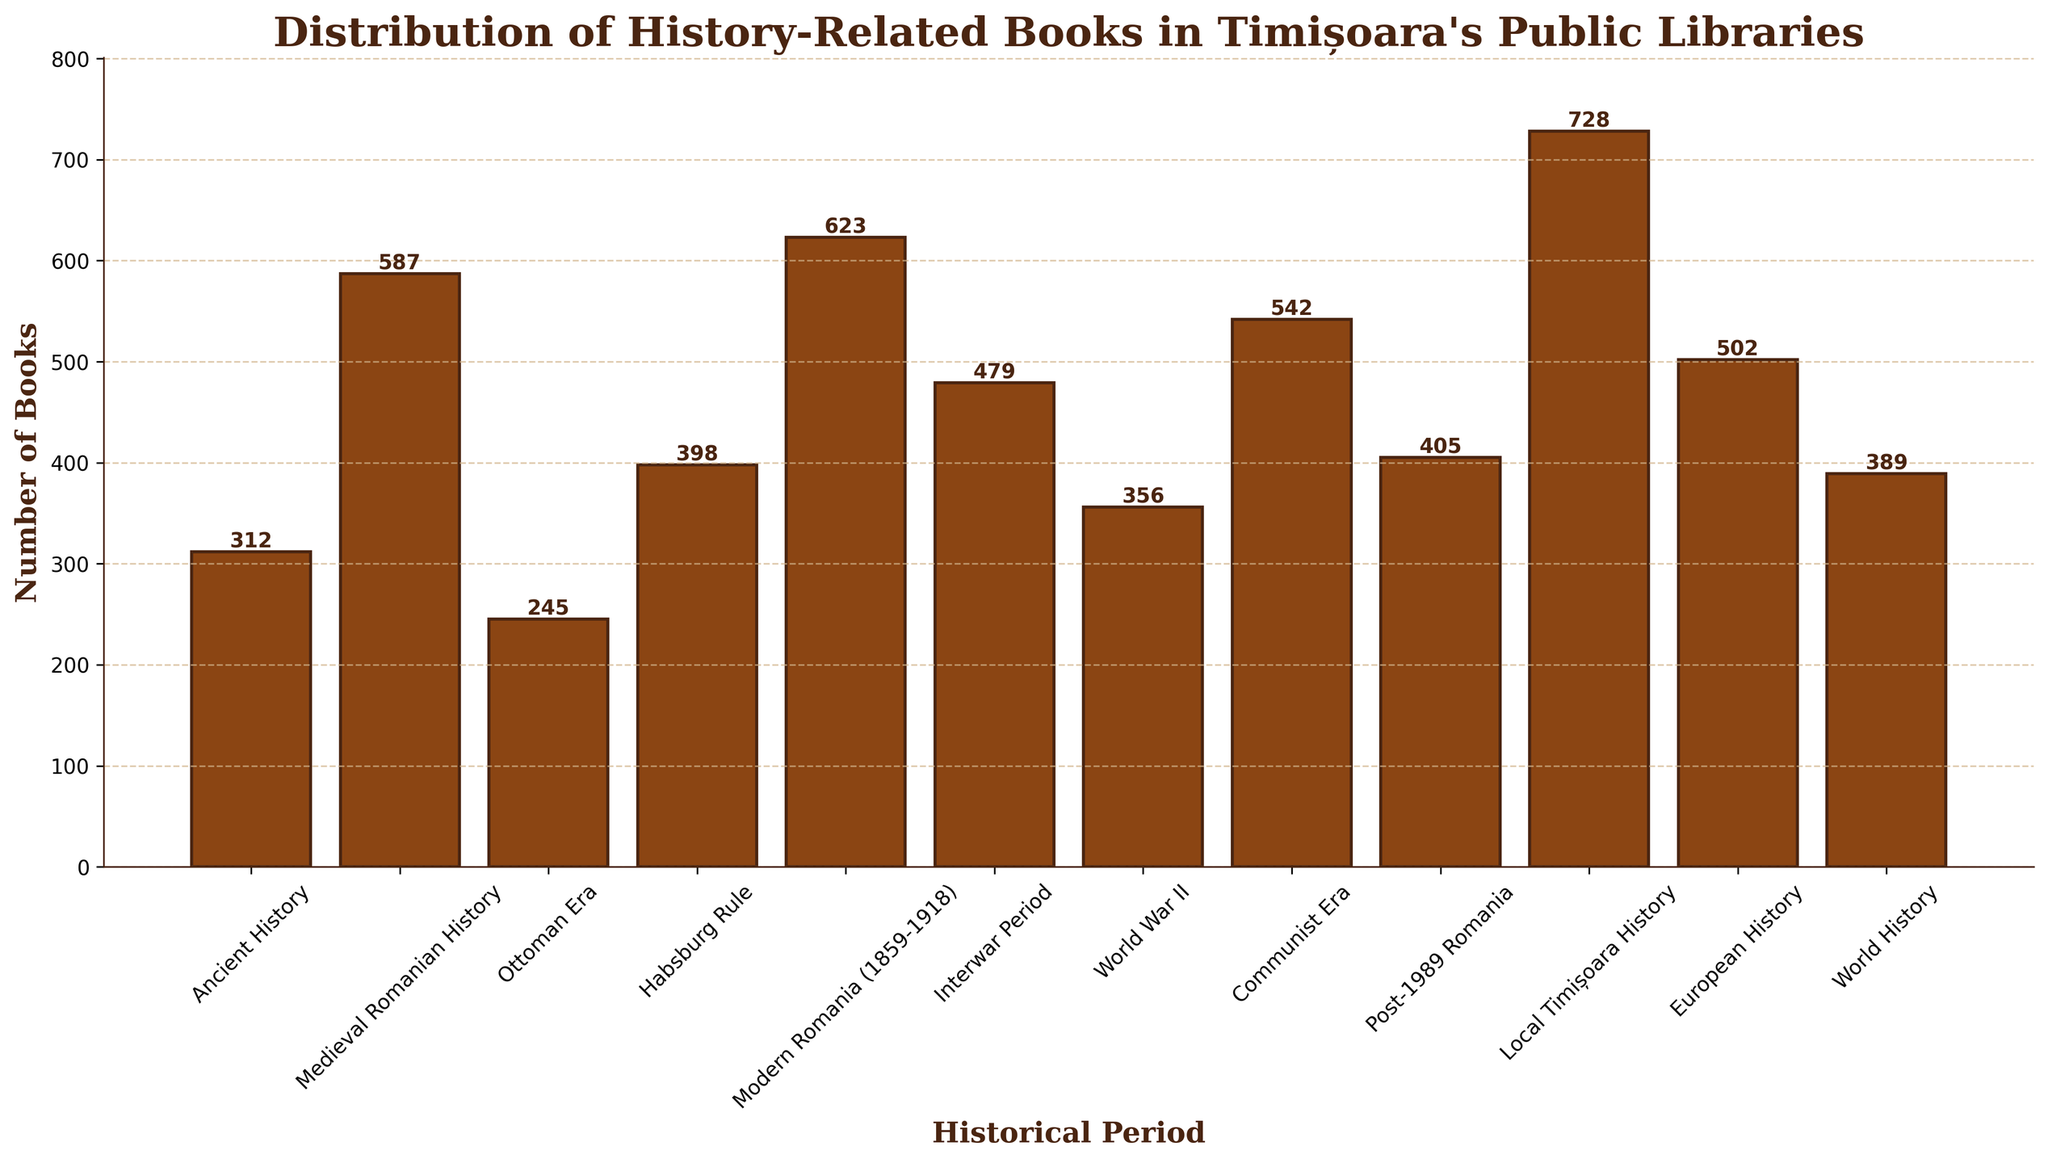Which historical period has the most books? The bar representing "Local Timișoara History" is the tallest, indicating it has the highest number of books.
Answer: Local Timișoara History Which historical period has the fewest books and how many? The bar representing "Ottoman Era" is the shortest, indicating it has the lowest number of books. The height of the bar shows 245 books.
Answer: Ottoman Era, 245 What is the total number of books for Ancient History and Medieval Romanian History combined? Add the number of books for "Ancient History" (312) and "Medieval Romanian History" (587). The sum is 312 + 587 = 899.
Answer: 899 How does the number of books in the Communist Era compare to the Interwar Period? The bar for "Communist Era" is taller than the bar for "Interwar Period". Specifically, Communist Era has 542 books while Interwar Period has 479 books. So, Communist Era has more books.
Answer: Communist Era has more books Which historical periods have more than 500 books? From the bars that extend above the 500 mark on the y-axis, these periods are: Medieval Romanian History (587), Modern Romania (623), Communist Era (542), and Local Timișoara History (728).
Answer: Medieval Romanian History, Modern Romania, Communist Era, Local Timișoara History What is the difference in the number of books between World War II and Post-1989 Romania? Subtract the number of books in "World War II" (356) from "Post-1989 Romania" (405). The difference is 405 - 356 = 49.
Answer: 49 Calculate the average number of books for the periods Ottoman Era, Habsburg Rule, and Modern Romania. Sum the number of books for these periods: Ottoman Era (245) + Habsburg Rule (398) + Modern Romania (623) = 1266. Divide by 3 to get the average: 1266 / 3 = 422.
Answer: 422 Which period has the closest number of books to World History and how many books is this value off by? "Post-1989 Romania" has 405 books, closest to "World History" with 389 books. The difference is 405 - 389 = 16.
Answer: Post-1989 Romania, 16 Is the number of books in the Local Timișoara History more than twice the number in the Ottoman Era? The number for Local Timișoara History is 728. Twice the number in Ottoman Era is 2 * 245 = 490. Since 728 > 490, it is indeed more.
Answer: Yes 